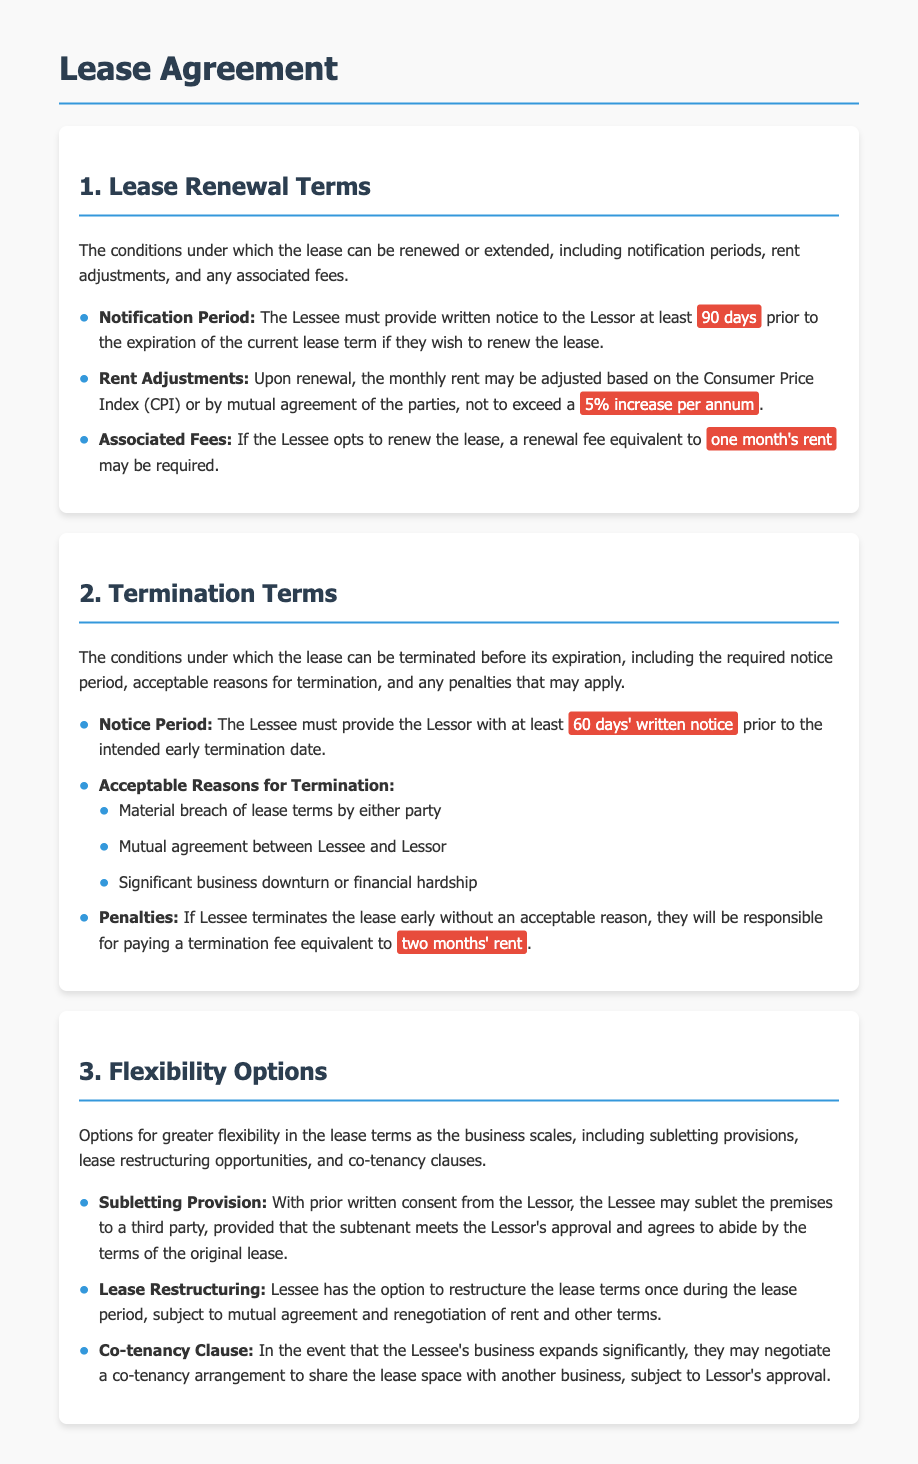What is the notification period for lease renewal? The Lessee must provide written notice to the Lessor at least 90 days prior to the expiration of the current lease term if they wish to renew the lease.
Answer: 90 days What is the maximum rent increase per annum upon renewal? Upon renewal, the monthly rent may be adjusted based on the Consumer Price Index or mutual agreement, not to exceed a 5% increase per annum.
Answer: 5% What is the renewal fee if the Lessee opts to renew the lease? A renewal fee equivalent to one month's rent may be required if the Lessee opts to renew the lease.
Answer: one month's rent What is the notice period required for early termination? The Lessee must provide the Lessor with at least 60 days' written notice prior to the intended early termination date.
Answer: 60 days What are acceptable reasons for early termination of the lease? Acceptable reasons include material breach of lease terms, mutual agreement, or significant business downturn.
Answer: material breach, mutual agreement, significant business downturn What penalty is incurred for early termination without an acceptable reason? If Lessee terminates the lease early without an acceptable reason, they will be responsible for paying a termination fee equivalent to two months' rent.
Answer: two months' rent Can the Lessee sublet the premises? Yes, the Lessee may sublet the premises with prior written consent from the Lessor, provided that the subtenant is approved.
Answer: Yes How many times can the lease be restructured? The Lessee has the option to restructure the lease terms once during the lease period.
Answer: once What does the co-tenancy clause allow the Lessee to do? The co-tenancy clause allows the Lessee to negotiate a co-tenancy arrangement to share the lease space with another business, subject to Lessor's approval.
Answer: share lease space with another business 